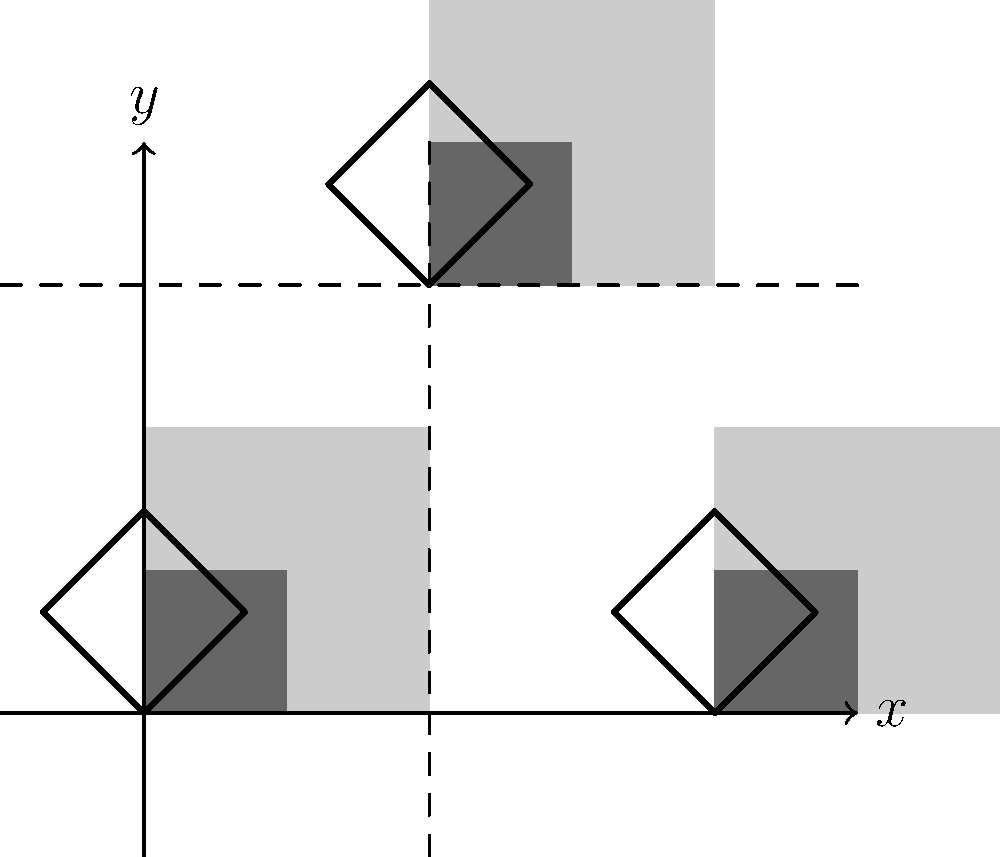The diagram shows a series of geometric patterns inspired by African textile designs. If the entire design is reflected first across the y-axis and then across the line y = 1.5, how many complete diamond shapes (formed by the rotated squares) will be in the final image? Let's approach this step-by-step:

1) First, let's count the original diamond shapes:
   - There are 3 complete diamond shapes in the original design.

2) Reflection across the y-axis:
   - This will double the number of shapes, creating a mirror image on the left side.
   - After this reflection, we will have 6 diamond shapes.

3) Reflection across the line y = 1.5:
   - This line is represented by the dashed horizontal line in the upper part of the diagram.
   - This reflection will double the shapes again, creating a mirror image above the line.
   - The shapes that were partially cut off at the top of the original image will now be completed in the reflection.

4) Final count:
   - The 6 shapes from step 2 will be reflected, giving us 12 shapes.
   - The partial shapes at the top will form 3 additional complete diamonds in the reflection.

5) Total number of complete diamond shapes:
   - 12 (from the full reflection) + 3 (from the completed partial shapes) = 15

Therefore, the final image will contain 15 complete diamond shapes.
Answer: 15 